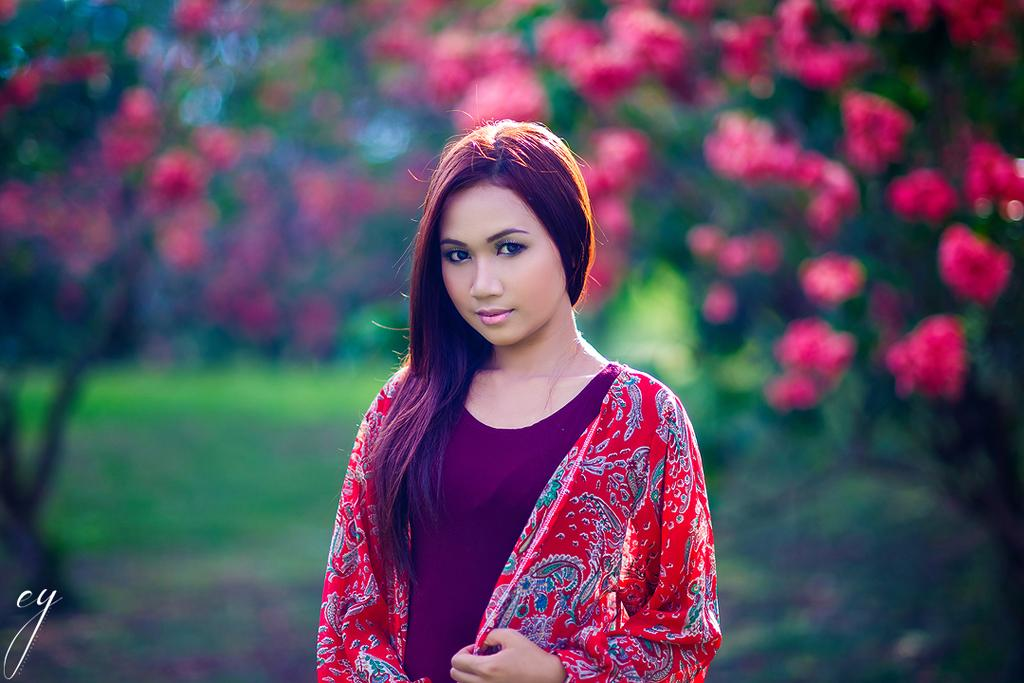What is the main subject in the foreground of the image? There is a woman standing in the foreground of the image. What can be seen in the background of the image? There are flowers and greenery in the background of the image. What type of plate is being used by the band in the image? There is no band present in the image, so there is no plate being used by a band. 